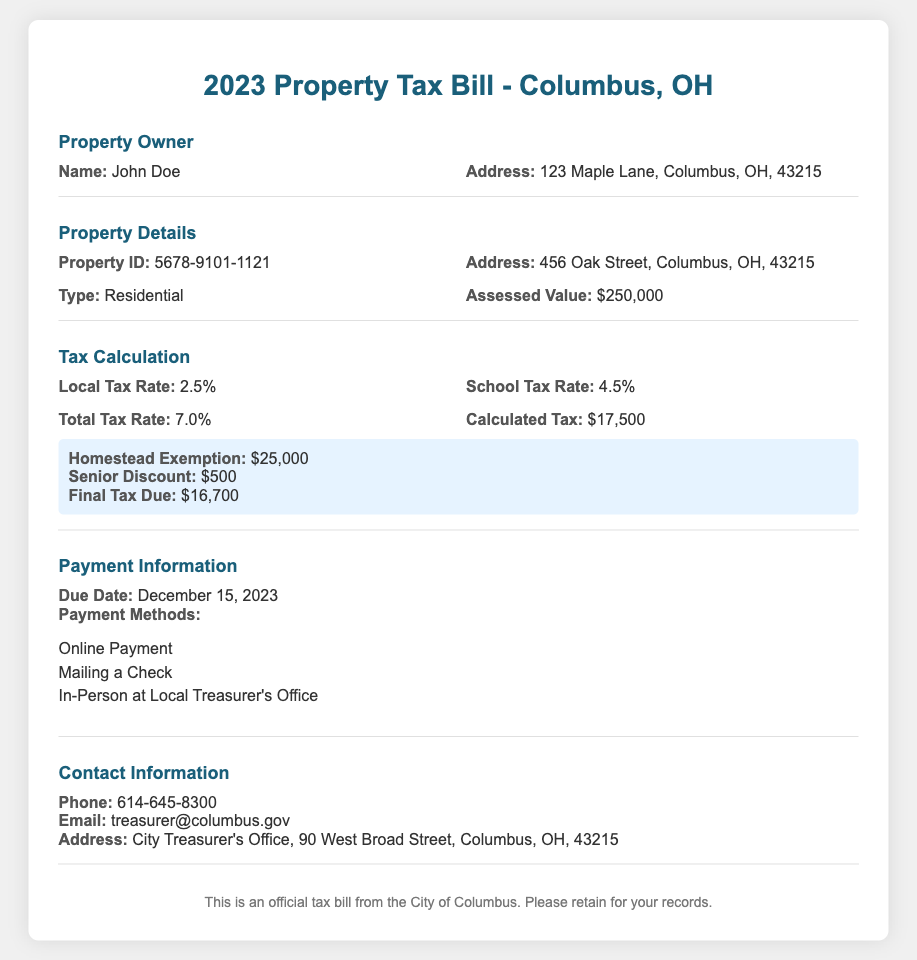What is the name of the property owner? The document specifies the property owner's name, which is John Doe.
Answer: John Doe What is the assessed value of the property? The assessed value listed in the document is the estimated worth of the property.
Answer: $250,000 What is the local tax rate? The local tax rate is mentioned as part of the tax calculation section in the document.
Answer: 2.5% What is the final tax due after exemptions? The final tax due takes into account the exemptions and is calculated in the tax calculation section.
Answer: $16,700 What is the due date for the property tax payment? The due date is clearly stated in the payment information section of the document.
Answer: December 15, 2023 How much is the Homestead Exemption? The Homestead Exemption amount is specified in the highlight section of the tax calculation.
Answer: $25,000 What is the total tax rate? The total tax rate is derived from adding the local and school tax rates together.
Answer: 7.0% What discount is provided for seniors? The document mentions a specific amount available as a discount for seniors under the exemptions.
Answer: $500 What contact number is provided for the City Treasurer's Office? The document includes a contact number for residents to reach out regarding their taxes.
Answer: 614-645-8300 